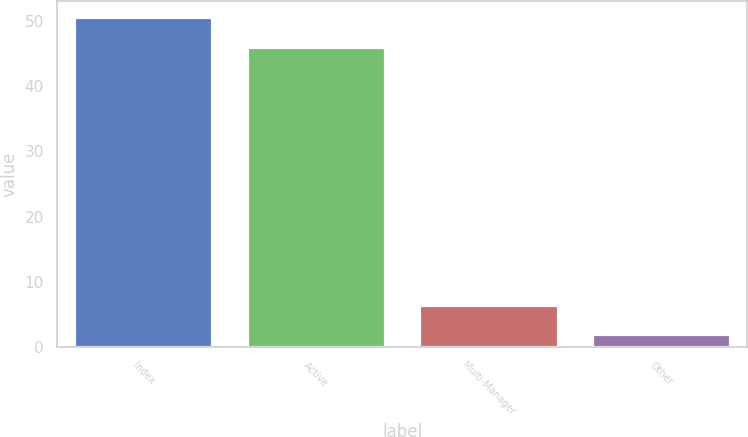<chart> <loc_0><loc_0><loc_500><loc_500><bar_chart><fcel>Index<fcel>Active<fcel>Multi-Manager<fcel>Other<nl><fcel>50.5<fcel>46<fcel>6.5<fcel>2<nl></chart> 